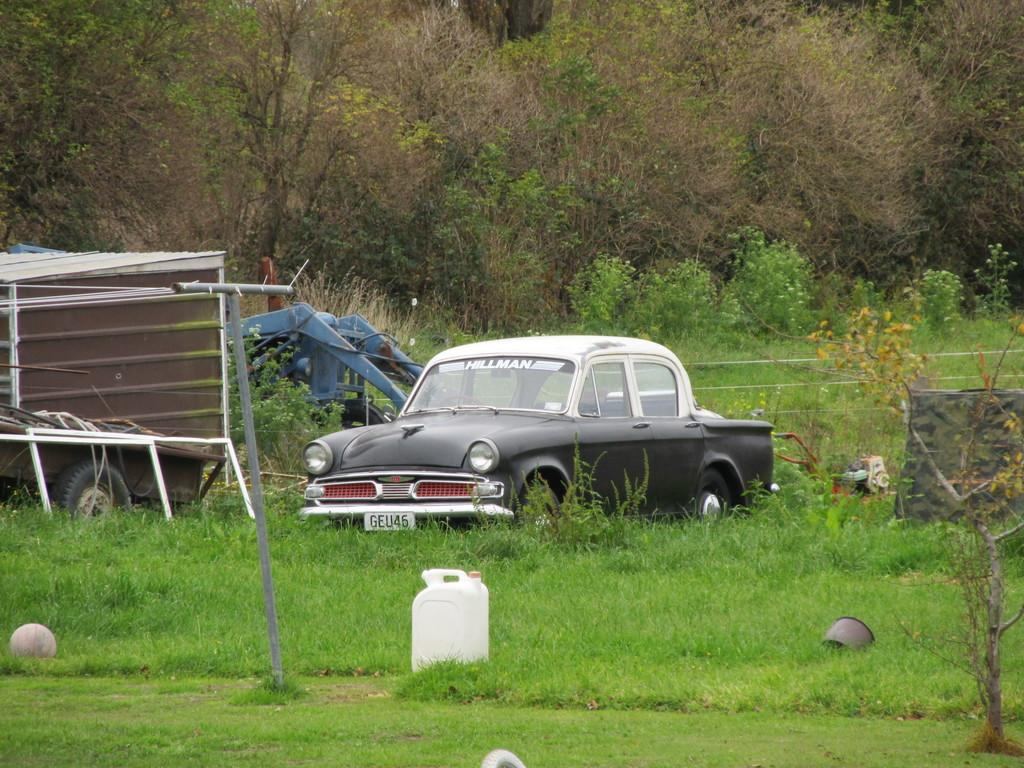What type of car can be seen in the image? There is a gray car in the image. What natural elements are visible in the image? Trees and grass are present in the image. Are there any other vehicles in the image besides the gray car? Yes, there is another vehicle in the image. What type of mine is visible in the image? There is no mine present in the image. How much payment is required to enter the area shown in the image? There is no indication of any payment required to enter the area shown in the image. 